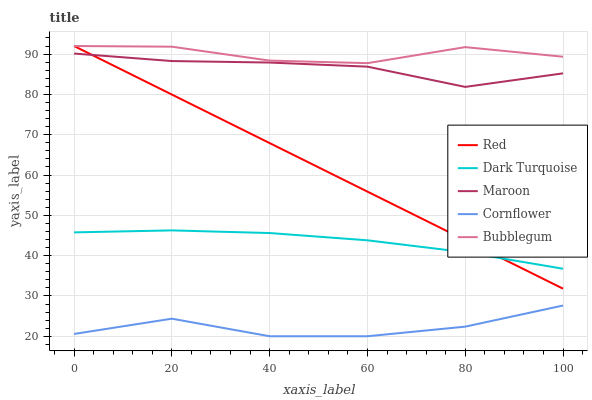Does Cornflower have the minimum area under the curve?
Answer yes or no. Yes. Does Bubblegum have the maximum area under the curve?
Answer yes or no. Yes. Does Maroon have the minimum area under the curve?
Answer yes or no. No. Does Maroon have the maximum area under the curve?
Answer yes or no. No. Is Red the smoothest?
Answer yes or no. Yes. Is Cornflower the roughest?
Answer yes or no. Yes. Is Bubblegum the smoothest?
Answer yes or no. No. Is Bubblegum the roughest?
Answer yes or no. No. Does Cornflower have the lowest value?
Answer yes or no. Yes. Does Maroon have the lowest value?
Answer yes or no. No. Does Red have the highest value?
Answer yes or no. Yes. Does Maroon have the highest value?
Answer yes or no. No. Is Maroon less than Bubblegum?
Answer yes or no. Yes. Is Red greater than Cornflower?
Answer yes or no. Yes. Does Dark Turquoise intersect Red?
Answer yes or no. Yes. Is Dark Turquoise less than Red?
Answer yes or no. No. Is Dark Turquoise greater than Red?
Answer yes or no. No. Does Maroon intersect Bubblegum?
Answer yes or no. No. 